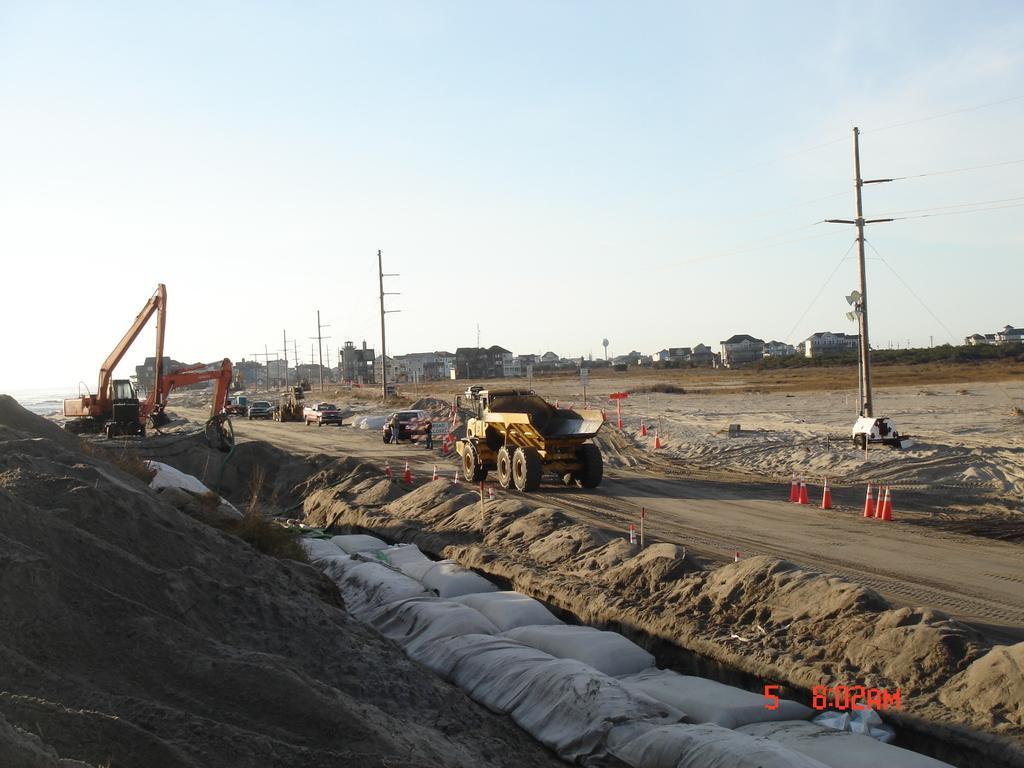Could you give a brief overview of what you see in this image? Here we can see vehicles, poles, traffic cones and objects. Background we can see buildings and sky. 